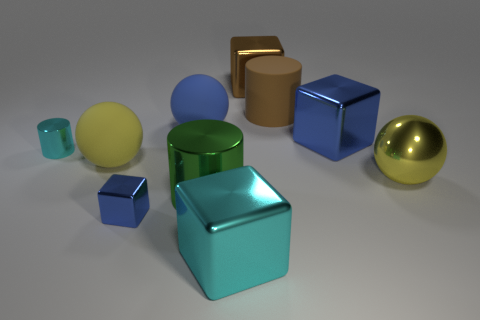What color is the tiny cylinder that is the same material as the large green cylinder? The tiny cylinder that shares the same glossy material as the large green cylinder is cyan. It appears to have a reflective surface similar to the larger cylinder, suggesting it's likely made of the same material. 